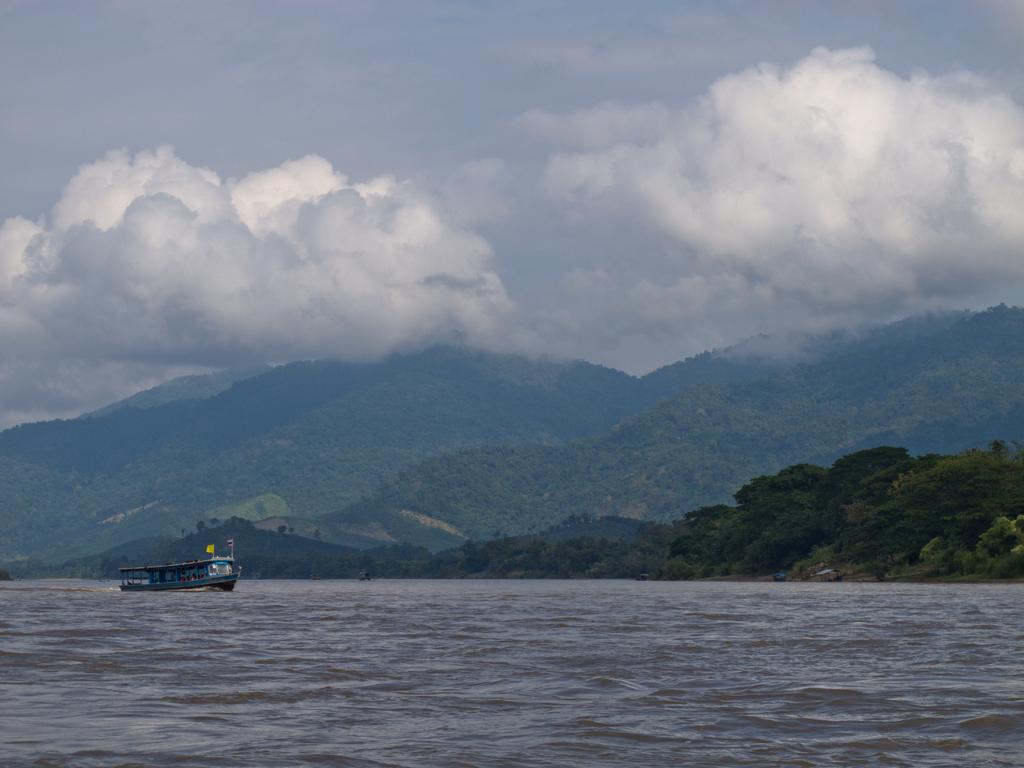What is the main subject of the image? The main subject of the image is a boat. Where is the boat located? The boat is on the water. What can be seen in the background of the image? There are trees, mountains, and clouds in the sky in the background of the image. Reasoning: Let'g: Let's think step by step in order to produce the conversation. We start by identifying the main subject of the image, which is the boat. Next, we describe the location of the boat, which is on the water. Then, we observe the background of the image, noting the presence of trees, mountains, and clouds in the sky. Absurd Question/Answer: What type of drain can be seen in the image? There is no drain present in the image; it features a boat on the water with a background of trees, mountains, and clouds. How does the boat fold in the image? Boats do not fold; they are rigid structures. 